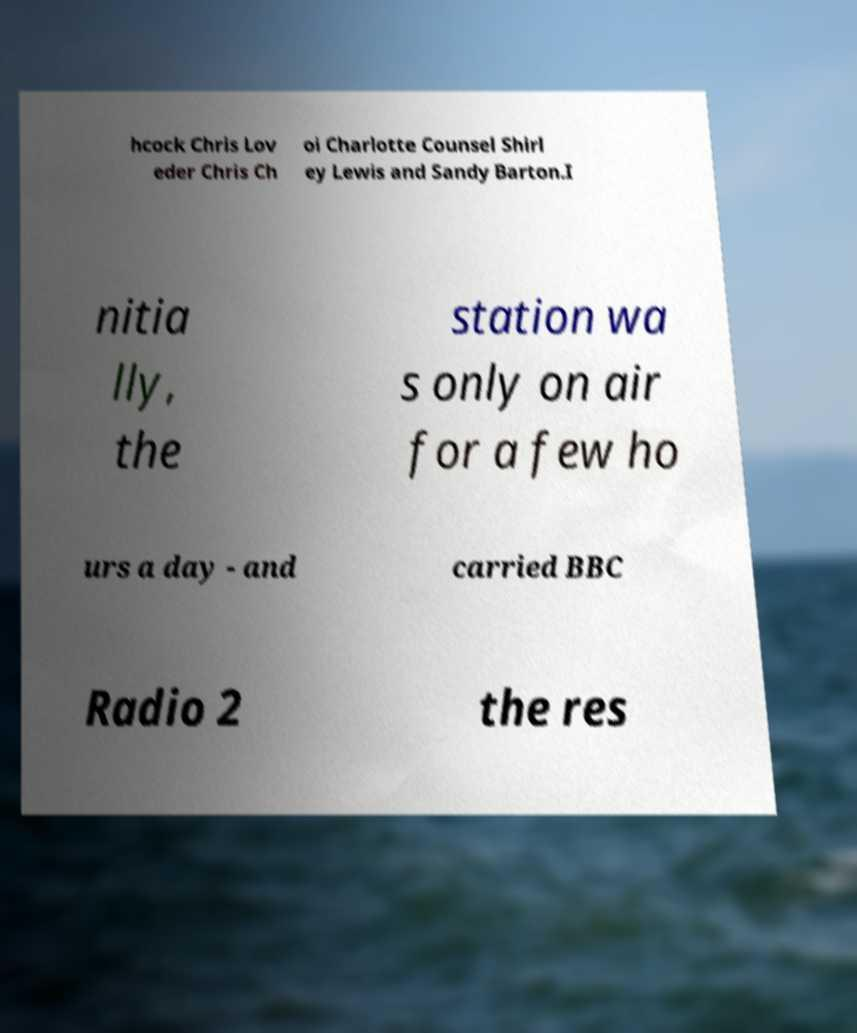There's text embedded in this image that I need extracted. Can you transcribe it verbatim? hcock Chris Lov eder Chris Ch oi Charlotte Counsel Shirl ey Lewis and Sandy Barton.I nitia lly, the station wa s only on air for a few ho urs a day - and carried BBC Radio 2 the res 